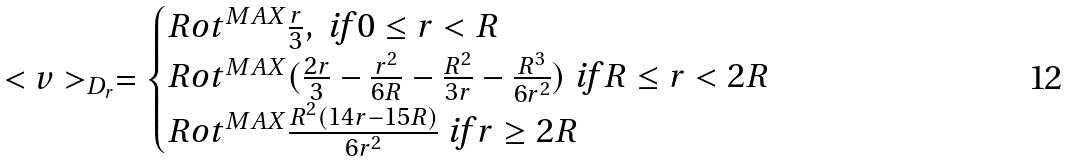Convert formula to latex. <formula><loc_0><loc_0><loc_500><loc_500>< v > _ { D _ { r } } = \begin{cases} R o t ^ { M A X } \frac { r } { 3 } , \text { if } 0 \leq r < R \\ R o t ^ { M A X } ( \frac { 2 r } { 3 } - \frac { r ^ { 2 } } { 6 R } - \frac { R ^ { 2 } } { 3 r } - \frac { R ^ { 3 } } { 6 r ^ { 2 } } ) \text { if } R \leq r < 2 R \\ R o t ^ { M A X } \frac { R ^ { 2 } ( 1 4 r - 1 5 R ) } { 6 r ^ { 2 } } \text { if } r \geq 2 R \end{cases}</formula> 